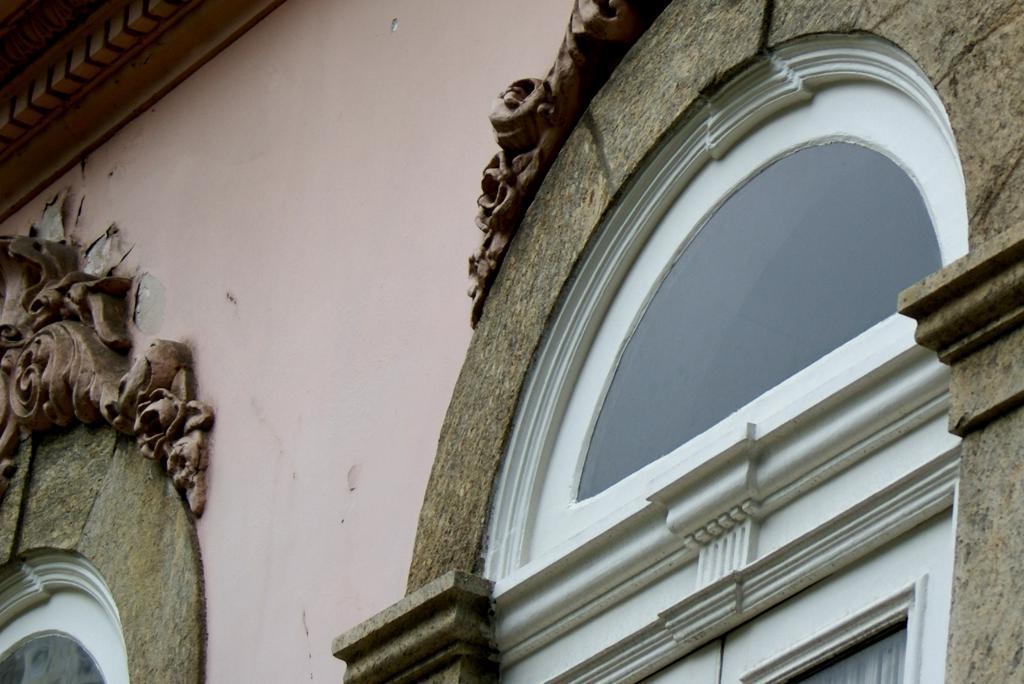Can you describe this image briefly? In this image in the foreground there is one building, and there are two glass windows. 